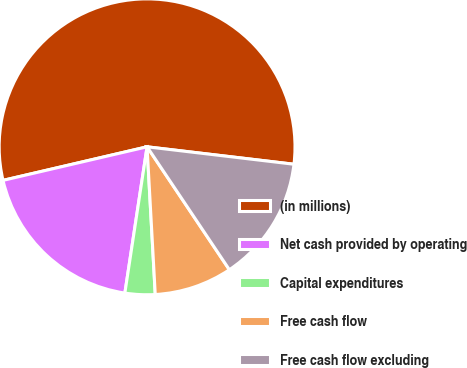<chart> <loc_0><loc_0><loc_500><loc_500><pie_chart><fcel>(in millions)<fcel>Net cash provided by operating<fcel>Capital expenditures<fcel>Free cash flow<fcel>Free cash flow excluding<nl><fcel>55.53%<fcel>18.96%<fcel>3.28%<fcel>8.51%<fcel>13.73%<nl></chart> 